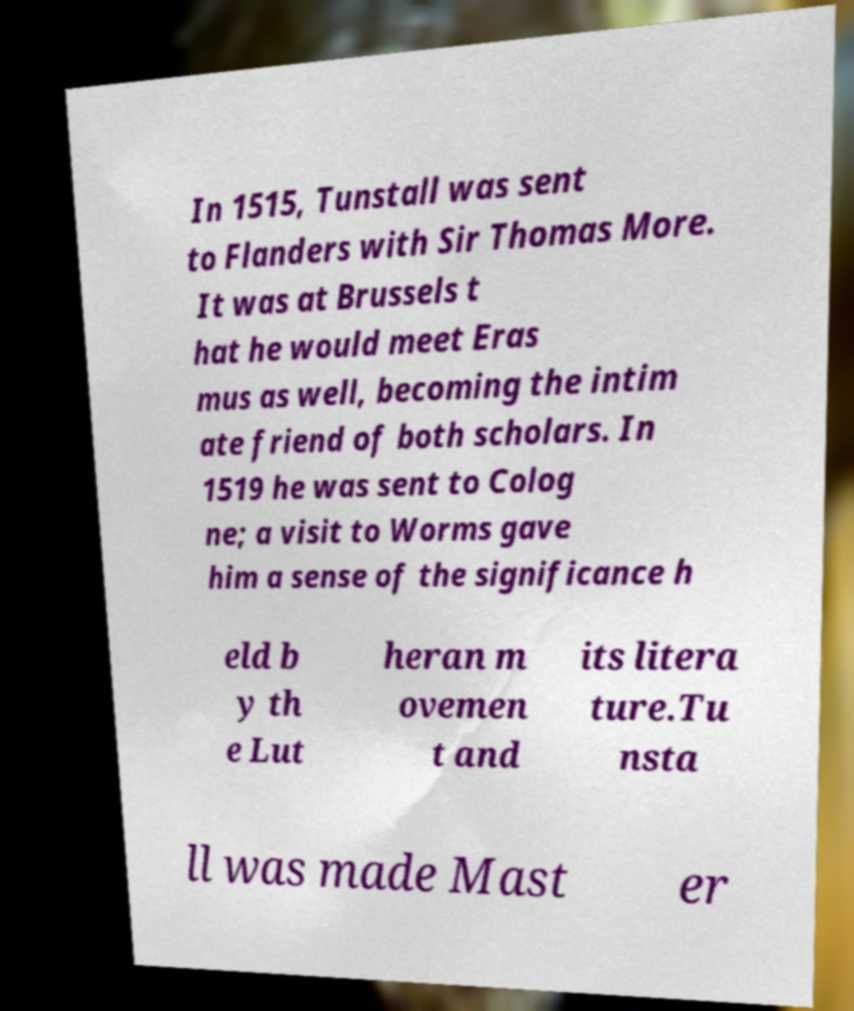There's text embedded in this image that I need extracted. Can you transcribe it verbatim? In 1515, Tunstall was sent to Flanders with Sir Thomas More. It was at Brussels t hat he would meet Eras mus as well, becoming the intim ate friend of both scholars. In 1519 he was sent to Colog ne; a visit to Worms gave him a sense of the significance h eld b y th e Lut heran m ovemen t and its litera ture.Tu nsta ll was made Mast er 